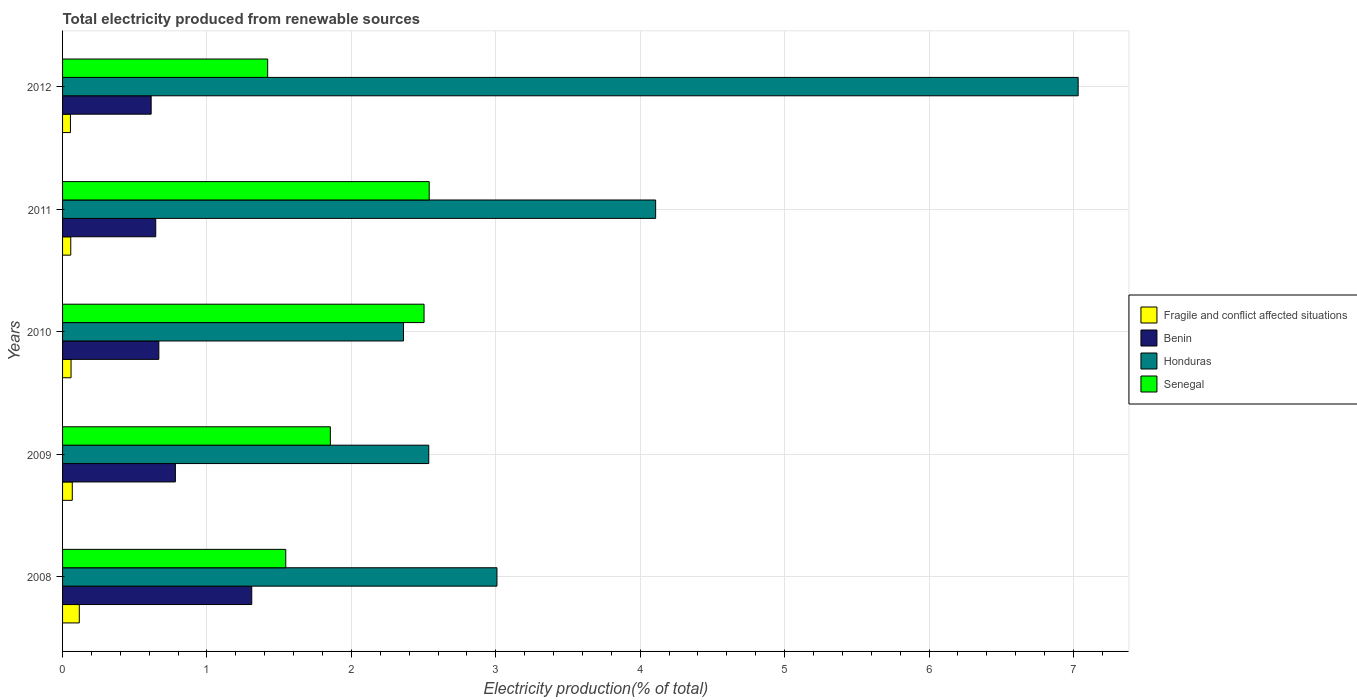How many different coloured bars are there?
Keep it short and to the point. 4. Are the number of bars on each tick of the Y-axis equal?
Provide a succinct answer. Yes. How many bars are there on the 2nd tick from the top?
Offer a terse response. 4. How many bars are there on the 4th tick from the bottom?
Keep it short and to the point. 4. In how many cases, is the number of bars for a given year not equal to the number of legend labels?
Your answer should be compact. 0. What is the total electricity produced in Benin in 2011?
Make the answer very short. 0.65. Across all years, what is the maximum total electricity produced in Honduras?
Make the answer very short. 7.03. Across all years, what is the minimum total electricity produced in Honduras?
Give a very brief answer. 2.36. In which year was the total electricity produced in Benin maximum?
Make the answer very short. 2008. What is the total total electricity produced in Fragile and conflict affected situations in the graph?
Your response must be concise. 0.35. What is the difference between the total electricity produced in Honduras in 2008 and that in 2009?
Keep it short and to the point. 0.47. What is the difference between the total electricity produced in Fragile and conflict affected situations in 2010 and the total electricity produced in Benin in 2012?
Offer a very short reply. -0.55. What is the average total electricity produced in Fragile and conflict affected situations per year?
Keep it short and to the point. 0.07. In the year 2008, what is the difference between the total electricity produced in Honduras and total electricity produced in Senegal?
Offer a very short reply. 1.46. In how many years, is the total electricity produced in Fragile and conflict affected situations greater than 3.8 %?
Your answer should be very brief. 0. What is the ratio of the total electricity produced in Honduras in 2008 to that in 2011?
Ensure brevity in your answer.  0.73. Is the difference between the total electricity produced in Honduras in 2008 and 2010 greater than the difference between the total electricity produced in Senegal in 2008 and 2010?
Offer a very short reply. Yes. What is the difference between the highest and the second highest total electricity produced in Senegal?
Provide a succinct answer. 0.04. What is the difference between the highest and the lowest total electricity produced in Fragile and conflict affected situations?
Your response must be concise. 0.06. In how many years, is the total electricity produced in Senegal greater than the average total electricity produced in Senegal taken over all years?
Ensure brevity in your answer.  2. What does the 3rd bar from the top in 2012 represents?
Offer a terse response. Benin. What does the 2nd bar from the bottom in 2008 represents?
Provide a succinct answer. Benin. What is the difference between two consecutive major ticks on the X-axis?
Your answer should be compact. 1. Does the graph contain grids?
Your answer should be compact. Yes. How many legend labels are there?
Provide a succinct answer. 4. How are the legend labels stacked?
Make the answer very short. Vertical. What is the title of the graph?
Give a very brief answer. Total electricity produced from renewable sources. What is the label or title of the Y-axis?
Provide a short and direct response. Years. What is the Electricity production(% of total) of Fragile and conflict affected situations in 2008?
Provide a short and direct response. 0.12. What is the Electricity production(% of total) in Benin in 2008?
Offer a very short reply. 1.31. What is the Electricity production(% of total) of Honduras in 2008?
Ensure brevity in your answer.  3.01. What is the Electricity production(% of total) of Senegal in 2008?
Ensure brevity in your answer.  1.55. What is the Electricity production(% of total) in Fragile and conflict affected situations in 2009?
Offer a very short reply. 0.07. What is the Electricity production(% of total) in Benin in 2009?
Give a very brief answer. 0.78. What is the Electricity production(% of total) in Honduras in 2009?
Offer a very short reply. 2.54. What is the Electricity production(% of total) of Senegal in 2009?
Offer a terse response. 1.85. What is the Electricity production(% of total) of Fragile and conflict affected situations in 2010?
Your response must be concise. 0.06. What is the Electricity production(% of total) of Benin in 2010?
Your answer should be very brief. 0.67. What is the Electricity production(% of total) in Honduras in 2010?
Your response must be concise. 2.36. What is the Electricity production(% of total) in Senegal in 2010?
Keep it short and to the point. 2.5. What is the Electricity production(% of total) of Fragile and conflict affected situations in 2011?
Your response must be concise. 0.06. What is the Electricity production(% of total) in Benin in 2011?
Give a very brief answer. 0.65. What is the Electricity production(% of total) of Honduras in 2011?
Offer a terse response. 4.11. What is the Electricity production(% of total) in Senegal in 2011?
Provide a short and direct response. 2.54. What is the Electricity production(% of total) of Fragile and conflict affected situations in 2012?
Your answer should be very brief. 0.05. What is the Electricity production(% of total) of Benin in 2012?
Your response must be concise. 0.61. What is the Electricity production(% of total) in Honduras in 2012?
Provide a short and direct response. 7.03. What is the Electricity production(% of total) of Senegal in 2012?
Offer a terse response. 1.42. Across all years, what is the maximum Electricity production(% of total) of Fragile and conflict affected situations?
Offer a terse response. 0.12. Across all years, what is the maximum Electricity production(% of total) of Benin?
Ensure brevity in your answer.  1.31. Across all years, what is the maximum Electricity production(% of total) in Honduras?
Keep it short and to the point. 7.03. Across all years, what is the maximum Electricity production(% of total) of Senegal?
Your response must be concise. 2.54. Across all years, what is the minimum Electricity production(% of total) in Fragile and conflict affected situations?
Give a very brief answer. 0.05. Across all years, what is the minimum Electricity production(% of total) in Benin?
Give a very brief answer. 0.61. Across all years, what is the minimum Electricity production(% of total) in Honduras?
Offer a very short reply. 2.36. Across all years, what is the minimum Electricity production(% of total) in Senegal?
Ensure brevity in your answer.  1.42. What is the total Electricity production(% of total) in Fragile and conflict affected situations in the graph?
Make the answer very short. 0.35. What is the total Electricity production(% of total) in Benin in the graph?
Your answer should be compact. 4.02. What is the total Electricity production(% of total) of Honduras in the graph?
Your answer should be compact. 19.04. What is the total Electricity production(% of total) in Senegal in the graph?
Keep it short and to the point. 9.86. What is the difference between the Electricity production(% of total) of Fragile and conflict affected situations in 2008 and that in 2009?
Keep it short and to the point. 0.05. What is the difference between the Electricity production(% of total) in Benin in 2008 and that in 2009?
Give a very brief answer. 0.53. What is the difference between the Electricity production(% of total) in Honduras in 2008 and that in 2009?
Ensure brevity in your answer.  0.47. What is the difference between the Electricity production(% of total) of Senegal in 2008 and that in 2009?
Give a very brief answer. -0.31. What is the difference between the Electricity production(% of total) of Fragile and conflict affected situations in 2008 and that in 2010?
Offer a very short reply. 0.06. What is the difference between the Electricity production(% of total) of Benin in 2008 and that in 2010?
Offer a very short reply. 0.64. What is the difference between the Electricity production(% of total) of Honduras in 2008 and that in 2010?
Ensure brevity in your answer.  0.65. What is the difference between the Electricity production(% of total) in Senegal in 2008 and that in 2010?
Make the answer very short. -0.96. What is the difference between the Electricity production(% of total) in Fragile and conflict affected situations in 2008 and that in 2011?
Make the answer very short. 0.06. What is the difference between the Electricity production(% of total) in Benin in 2008 and that in 2011?
Offer a very short reply. 0.66. What is the difference between the Electricity production(% of total) in Honduras in 2008 and that in 2011?
Your response must be concise. -1.1. What is the difference between the Electricity production(% of total) in Senegal in 2008 and that in 2011?
Make the answer very short. -0.99. What is the difference between the Electricity production(% of total) of Fragile and conflict affected situations in 2008 and that in 2012?
Provide a succinct answer. 0.06. What is the difference between the Electricity production(% of total) in Benin in 2008 and that in 2012?
Provide a succinct answer. 0.7. What is the difference between the Electricity production(% of total) of Honduras in 2008 and that in 2012?
Your answer should be compact. -4.02. What is the difference between the Electricity production(% of total) of Senegal in 2008 and that in 2012?
Offer a terse response. 0.13. What is the difference between the Electricity production(% of total) in Fragile and conflict affected situations in 2009 and that in 2010?
Give a very brief answer. 0.01. What is the difference between the Electricity production(% of total) in Benin in 2009 and that in 2010?
Your answer should be compact. 0.11. What is the difference between the Electricity production(% of total) of Honduras in 2009 and that in 2010?
Ensure brevity in your answer.  0.17. What is the difference between the Electricity production(% of total) of Senegal in 2009 and that in 2010?
Your answer should be compact. -0.65. What is the difference between the Electricity production(% of total) of Fragile and conflict affected situations in 2009 and that in 2011?
Provide a succinct answer. 0.01. What is the difference between the Electricity production(% of total) in Benin in 2009 and that in 2011?
Offer a very short reply. 0.14. What is the difference between the Electricity production(% of total) in Honduras in 2009 and that in 2011?
Ensure brevity in your answer.  -1.57. What is the difference between the Electricity production(% of total) of Senegal in 2009 and that in 2011?
Ensure brevity in your answer.  -0.68. What is the difference between the Electricity production(% of total) in Fragile and conflict affected situations in 2009 and that in 2012?
Keep it short and to the point. 0.01. What is the difference between the Electricity production(% of total) in Benin in 2009 and that in 2012?
Your response must be concise. 0.17. What is the difference between the Electricity production(% of total) in Honduras in 2009 and that in 2012?
Provide a succinct answer. -4.5. What is the difference between the Electricity production(% of total) in Senegal in 2009 and that in 2012?
Give a very brief answer. 0.43. What is the difference between the Electricity production(% of total) of Fragile and conflict affected situations in 2010 and that in 2011?
Your answer should be compact. 0. What is the difference between the Electricity production(% of total) of Benin in 2010 and that in 2011?
Provide a succinct answer. 0.02. What is the difference between the Electricity production(% of total) of Honduras in 2010 and that in 2011?
Your answer should be compact. -1.75. What is the difference between the Electricity production(% of total) in Senegal in 2010 and that in 2011?
Ensure brevity in your answer.  -0.04. What is the difference between the Electricity production(% of total) in Fragile and conflict affected situations in 2010 and that in 2012?
Keep it short and to the point. 0. What is the difference between the Electricity production(% of total) of Benin in 2010 and that in 2012?
Your response must be concise. 0.05. What is the difference between the Electricity production(% of total) of Honduras in 2010 and that in 2012?
Provide a short and direct response. -4.67. What is the difference between the Electricity production(% of total) of Senegal in 2010 and that in 2012?
Your response must be concise. 1.08. What is the difference between the Electricity production(% of total) of Fragile and conflict affected situations in 2011 and that in 2012?
Provide a succinct answer. 0. What is the difference between the Electricity production(% of total) of Benin in 2011 and that in 2012?
Offer a terse response. 0.03. What is the difference between the Electricity production(% of total) of Honduras in 2011 and that in 2012?
Offer a terse response. -2.93. What is the difference between the Electricity production(% of total) in Senegal in 2011 and that in 2012?
Your answer should be compact. 1.12. What is the difference between the Electricity production(% of total) in Fragile and conflict affected situations in 2008 and the Electricity production(% of total) in Benin in 2009?
Your response must be concise. -0.67. What is the difference between the Electricity production(% of total) in Fragile and conflict affected situations in 2008 and the Electricity production(% of total) in Honduras in 2009?
Provide a short and direct response. -2.42. What is the difference between the Electricity production(% of total) in Fragile and conflict affected situations in 2008 and the Electricity production(% of total) in Senegal in 2009?
Keep it short and to the point. -1.74. What is the difference between the Electricity production(% of total) in Benin in 2008 and the Electricity production(% of total) in Honduras in 2009?
Offer a very short reply. -1.23. What is the difference between the Electricity production(% of total) in Benin in 2008 and the Electricity production(% of total) in Senegal in 2009?
Your answer should be very brief. -0.54. What is the difference between the Electricity production(% of total) of Honduras in 2008 and the Electricity production(% of total) of Senegal in 2009?
Your response must be concise. 1.15. What is the difference between the Electricity production(% of total) of Fragile and conflict affected situations in 2008 and the Electricity production(% of total) of Benin in 2010?
Your response must be concise. -0.55. What is the difference between the Electricity production(% of total) of Fragile and conflict affected situations in 2008 and the Electricity production(% of total) of Honduras in 2010?
Offer a very short reply. -2.25. What is the difference between the Electricity production(% of total) of Fragile and conflict affected situations in 2008 and the Electricity production(% of total) of Senegal in 2010?
Offer a terse response. -2.39. What is the difference between the Electricity production(% of total) of Benin in 2008 and the Electricity production(% of total) of Honduras in 2010?
Give a very brief answer. -1.05. What is the difference between the Electricity production(% of total) of Benin in 2008 and the Electricity production(% of total) of Senegal in 2010?
Ensure brevity in your answer.  -1.19. What is the difference between the Electricity production(% of total) of Honduras in 2008 and the Electricity production(% of total) of Senegal in 2010?
Your response must be concise. 0.5. What is the difference between the Electricity production(% of total) in Fragile and conflict affected situations in 2008 and the Electricity production(% of total) in Benin in 2011?
Keep it short and to the point. -0.53. What is the difference between the Electricity production(% of total) of Fragile and conflict affected situations in 2008 and the Electricity production(% of total) of Honduras in 2011?
Provide a succinct answer. -3.99. What is the difference between the Electricity production(% of total) of Fragile and conflict affected situations in 2008 and the Electricity production(% of total) of Senegal in 2011?
Offer a terse response. -2.42. What is the difference between the Electricity production(% of total) in Benin in 2008 and the Electricity production(% of total) in Honduras in 2011?
Your answer should be very brief. -2.8. What is the difference between the Electricity production(% of total) of Benin in 2008 and the Electricity production(% of total) of Senegal in 2011?
Make the answer very short. -1.23. What is the difference between the Electricity production(% of total) in Honduras in 2008 and the Electricity production(% of total) in Senegal in 2011?
Give a very brief answer. 0.47. What is the difference between the Electricity production(% of total) of Fragile and conflict affected situations in 2008 and the Electricity production(% of total) of Benin in 2012?
Offer a terse response. -0.5. What is the difference between the Electricity production(% of total) of Fragile and conflict affected situations in 2008 and the Electricity production(% of total) of Honduras in 2012?
Ensure brevity in your answer.  -6.92. What is the difference between the Electricity production(% of total) of Fragile and conflict affected situations in 2008 and the Electricity production(% of total) of Senegal in 2012?
Your answer should be compact. -1.3. What is the difference between the Electricity production(% of total) of Benin in 2008 and the Electricity production(% of total) of Honduras in 2012?
Give a very brief answer. -5.72. What is the difference between the Electricity production(% of total) of Benin in 2008 and the Electricity production(% of total) of Senegal in 2012?
Give a very brief answer. -0.11. What is the difference between the Electricity production(% of total) of Honduras in 2008 and the Electricity production(% of total) of Senegal in 2012?
Offer a terse response. 1.59. What is the difference between the Electricity production(% of total) in Fragile and conflict affected situations in 2009 and the Electricity production(% of total) in Benin in 2010?
Your response must be concise. -0.6. What is the difference between the Electricity production(% of total) in Fragile and conflict affected situations in 2009 and the Electricity production(% of total) in Honduras in 2010?
Provide a short and direct response. -2.29. What is the difference between the Electricity production(% of total) in Fragile and conflict affected situations in 2009 and the Electricity production(% of total) in Senegal in 2010?
Ensure brevity in your answer.  -2.44. What is the difference between the Electricity production(% of total) in Benin in 2009 and the Electricity production(% of total) in Honduras in 2010?
Offer a terse response. -1.58. What is the difference between the Electricity production(% of total) in Benin in 2009 and the Electricity production(% of total) in Senegal in 2010?
Give a very brief answer. -1.72. What is the difference between the Electricity production(% of total) of Honduras in 2009 and the Electricity production(% of total) of Senegal in 2010?
Offer a terse response. 0.03. What is the difference between the Electricity production(% of total) in Fragile and conflict affected situations in 2009 and the Electricity production(% of total) in Benin in 2011?
Keep it short and to the point. -0.58. What is the difference between the Electricity production(% of total) in Fragile and conflict affected situations in 2009 and the Electricity production(% of total) in Honduras in 2011?
Your answer should be compact. -4.04. What is the difference between the Electricity production(% of total) of Fragile and conflict affected situations in 2009 and the Electricity production(% of total) of Senegal in 2011?
Offer a terse response. -2.47. What is the difference between the Electricity production(% of total) of Benin in 2009 and the Electricity production(% of total) of Honduras in 2011?
Keep it short and to the point. -3.33. What is the difference between the Electricity production(% of total) of Benin in 2009 and the Electricity production(% of total) of Senegal in 2011?
Your response must be concise. -1.76. What is the difference between the Electricity production(% of total) in Honduras in 2009 and the Electricity production(% of total) in Senegal in 2011?
Provide a short and direct response. -0. What is the difference between the Electricity production(% of total) in Fragile and conflict affected situations in 2009 and the Electricity production(% of total) in Benin in 2012?
Make the answer very short. -0.55. What is the difference between the Electricity production(% of total) in Fragile and conflict affected situations in 2009 and the Electricity production(% of total) in Honduras in 2012?
Offer a terse response. -6.97. What is the difference between the Electricity production(% of total) in Fragile and conflict affected situations in 2009 and the Electricity production(% of total) in Senegal in 2012?
Provide a succinct answer. -1.35. What is the difference between the Electricity production(% of total) of Benin in 2009 and the Electricity production(% of total) of Honduras in 2012?
Provide a short and direct response. -6.25. What is the difference between the Electricity production(% of total) of Benin in 2009 and the Electricity production(% of total) of Senegal in 2012?
Provide a succinct answer. -0.64. What is the difference between the Electricity production(% of total) of Honduras in 2009 and the Electricity production(% of total) of Senegal in 2012?
Ensure brevity in your answer.  1.12. What is the difference between the Electricity production(% of total) in Fragile and conflict affected situations in 2010 and the Electricity production(% of total) in Benin in 2011?
Give a very brief answer. -0.59. What is the difference between the Electricity production(% of total) in Fragile and conflict affected situations in 2010 and the Electricity production(% of total) in Honduras in 2011?
Your answer should be compact. -4.05. What is the difference between the Electricity production(% of total) in Fragile and conflict affected situations in 2010 and the Electricity production(% of total) in Senegal in 2011?
Keep it short and to the point. -2.48. What is the difference between the Electricity production(% of total) in Benin in 2010 and the Electricity production(% of total) in Honduras in 2011?
Your answer should be compact. -3.44. What is the difference between the Electricity production(% of total) in Benin in 2010 and the Electricity production(% of total) in Senegal in 2011?
Provide a short and direct response. -1.87. What is the difference between the Electricity production(% of total) of Honduras in 2010 and the Electricity production(% of total) of Senegal in 2011?
Your answer should be very brief. -0.18. What is the difference between the Electricity production(% of total) in Fragile and conflict affected situations in 2010 and the Electricity production(% of total) in Benin in 2012?
Offer a terse response. -0.55. What is the difference between the Electricity production(% of total) of Fragile and conflict affected situations in 2010 and the Electricity production(% of total) of Honduras in 2012?
Your answer should be compact. -6.97. What is the difference between the Electricity production(% of total) in Fragile and conflict affected situations in 2010 and the Electricity production(% of total) in Senegal in 2012?
Provide a succinct answer. -1.36. What is the difference between the Electricity production(% of total) of Benin in 2010 and the Electricity production(% of total) of Honduras in 2012?
Your answer should be compact. -6.37. What is the difference between the Electricity production(% of total) in Benin in 2010 and the Electricity production(% of total) in Senegal in 2012?
Make the answer very short. -0.75. What is the difference between the Electricity production(% of total) in Honduras in 2010 and the Electricity production(% of total) in Senegal in 2012?
Give a very brief answer. 0.94. What is the difference between the Electricity production(% of total) of Fragile and conflict affected situations in 2011 and the Electricity production(% of total) of Benin in 2012?
Provide a succinct answer. -0.56. What is the difference between the Electricity production(% of total) of Fragile and conflict affected situations in 2011 and the Electricity production(% of total) of Honduras in 2012?
Your answer should be compact. -6.98. What is the difference between the Electricity production(% of total) of Fragile and conflict affected situations in 2011 and the Electricity production(% of total) of Senegal in 2012?
Your response must be concise. -1.36. What is the difference between the Electricity production(% of total) in Benin in 2011 and the Electricity production(% of total) in Honduras in 2012?
Give a very brief answer. -6.39. What is the difference between the Electricity production(% of total) in Benin in 2011 and the Electricity production(% of total) in Senegal in 2012?
Provide a succinct answer. -0.78. What is the difference between the Electricity production(% of total) in Honduras in 2011 and the Electricity production(% of total) in Senegal in 2012?
Make the answer very short. 2.69. What is the average Electricity production(% of total) of Fragile and conflict affected situations per year?
Offer a terse response. 0.07. What is the average Electricity production(% of total) in Benin per year?
Your answer should be very brief. 0.8. What is the average Electricity production(% of total) in Honduras per year?
Make the answer very short. 3.81. What is the average Electricity production(% of total) of Senegal per year?
Ensure brevity in your answer.  1.97. In the year 2008, what is the difference between the Electricity production(% of total) of Fragile and conflict affected situations and Electricity production(% of total) of Benin?
Your response must be concise. -1.19. In the year 2008, what is the difference between the Electricity production(% of total) of Fragile and conflict affected situations and Electricity production(% of total) of Honduras?
Your response must be concise. -2.89. In the year 2008, what is the difference between the Electricity production(% of total) of Fragile and conflict affected situations and Electricity production(% of total) of Senegal?
Ensure brevity in your answer.  -1.43. In the year 2008, what is the difference between the Electricity production(% of total) in Benin and Electricity production(% of total) in Honduras?
Your answer should be very brief. -1.7. In the year 2008, what is the difference between the Electricity production(% of total) of Benin and Electricity production(% of total) of Senegal?
Offer a terse response. -0.24. In the year 2008, what is the difference between the Electricity production(% of total) of Honduras and Electricity production(% of total) of Senegal?
Your answer should be very brief. 1.46. In the year 2009, what is the difference between the Electricity production(% of total) of Fragile and conflict affected situations and Electricity production(% of total) of Benin?
Provide a succinct answer. -0.71. In the year 2009, what is the difference between the Electricity production(% of total) of Fragile and conflict affected situations and Electricity production(% of total) of Honduras?
Keep it short and to the point. -2.47. In the year 2009, what is the difference between the Electricity production(% of total) of Fragile and conflict affected situations and Electricity production(% of total) of Senegal?
Offer a terse response. -1.79. In the year 2009, what is the difference between the Electricity production(% of total) of Benin and Electricity production(% of total) of Honduras?
Your answer should be compact. -1.75. In the year 2009, what is the difference between the Electricity production(% of total) in Benin and Electricity production(% of total) in Senegal?
Offer a terse response. -1.07. In the year 2009, what is the difference between the Electricity production(% of total) in Honduras and Electricity production(% of total) in Senegal?
Ensure brevity in your answer.  0.68. In the year 2010, what is the difference between the Electricity production(% of total) in Fragile and conflict affected situations and Electricity production(% of total) in Benin?
Provide a short and direct response. -0.61. In the year 2010, what is the difference between the Electricity production(% of total) of Fragile and conflict affected situations and Electricity production(% of total) of Honduras?
Your response must be concise. -2.3. In the year 2010, what is the difference between the Electricity production(% of total) in Fragile and conflict affected situations and Electricity production(% of total) in Senegal?
Make the answer very short. -2.44. In the year 2010, what is the difference between the Electricity production(% of total) of Benin and Electricity production(% of total) of Honduras?
Give a very brief answer. -1.69. In the year 2010, what is the difference between the Electricity production(% of total) of Benin and Electricity production(% of total) of Senegal?
Your answer should be very brief. -1.84. In the year 2010, what is the difference between the Electricity production(% of total) in Honduras and Electricity production(% of total) in Senegal?
Provide a succinct answer. -0.14. In the year 2011, what is the difference between the Electricity production(% of total) in Fragile and conflict affected situations and Electricity production(% of total) in Benin?
Offer a terse response. -0.59. In the year 2011, what is the difference between the Electricity production(% of total) of Fragile and conflict affected situations and Electricity production(% of total) of Honduras?
Your response must be concise. -4.05. In the year 2011, what is the difference between the Electricity production(% of total) in Fragile and conflict affected situations and Electricity production(% of total) in Senegal?
Keep it short and to the point. -2.48. In the year 2011, what is the difference between the Electricity production(% of total) in Benin and Electricity production(% of total) in Honduras?
Give a very brief answer. -3.46. In the year 2011, what is the difference between the Electricity production(% of total) of Benin and Electricity production(% of total) of Senegal?
Your answer should be very brief. -1.89. In the year 2011, what is the difference between the Electricity production(% of total) of Honduras and Electricity production(% of total) of Senegal?
Give a very brief answer. 1.57. In the year 2012, what is the difference between the Electricity production(% of total) of Fragile and conflict affected situations and Electricity production(% of total) of Benin?
Your answer should be compact. -0.56. In the year 2012, what is the difference between the Electricity production(% of total) in Fragile and conflict affected situations and Electricity production(% of total) in Honduras?
Your answer should be compact. -6.98. In the year 2012, what is the difference between the Electricity production(% of total) of Fragile and conflict affected situations and Electricity production(% of total) of Senegal?
Your answer should be very brief. -1.37. In the year 2012, what is the difference between the Electricity production(% of total) in Benin and Electricity production(% of total) in Honduras?
Provide a short and direct response. -6.42. In the year 2012, what is the difference between the Electricity production(% of total) of Benin and Electricity production(% of total) of Senegal?
Your answer should be very brief. -0.81. In the year 2012, what is the difference between the Electricity production(% of total) in Honduras and Electricity production(% of total) in Senegal?
Make the answer very short. 5.61. What is the ratio of the Electricity production(% of total) of Fragile and conflict affected situations in 2008 to that in 2009?
Ensure brevity in your answer.  1.72. What is the ratio of the Electricity production(% of total) in Benin in 2008 to that in 2009?
Keep it short and to the point. 1.68. What is the ratio of the Electricity production(% of total) in Honduras in 2008 to that in 2009?
Offer a very short reply. 1.19. What is the ratio of the Electricity production(% of total) of Senegal in 2008 to that in 2009?
Keep it short and to the point. 0.83. What is the ratio of the Electricity production(% of total) in Fragile and conflict affected situations in 2008 to that in 2010?
Provide a succinct answer. 1.97. What is the ratio of the Electricity production(% of total) in Benin in 2008 to that in 2010?
Ensure brevity in your answer.  1.97. What is the ratio of the Electricity production(% of total) of Honduras in 2008 to that in 2010?
Give a very brief answer. 1.27. What is the ratio of the Electricity production(% of total) of Senegal in 2008 to that in 2010?
Your answer should be very brief. 0.62. What is the ratio of the Electricity production(% of total) in Fragile and conflict affected situations in 2008 to that in 2011?
Give a very brief answer. 2.04. What is the ratio of the Electricity production(% of total) in Benin in 2008 to that in 2011?
Your answer should be compact. 2.03. What is the ratio of the Electricity production(% of total) of Honduras in 2008 to that in 2011?
Your response must be concise. 0.73. What is the ratio of the Electricity production(% of total) of Senegal in 2008 to that in 2011?
Ensure brevity in your answer.  0.61. What is the ratio of the Electricity production(% of total) of Fragile and conflict affected situations in 2008 to that in 2012?
Offer a very short reply. 2.12. What is the ratio of the Electricity production(% of total) of Benin in 2008 to that in 2012?
Your answer should be compact. 2.14. What is the ratio of the Electricity production(% of total) in Honduras in 2008 to that in 2012?
Your answer should be compact. 0.43. What is the ratio of the Electricity production(% of total) in Senegal in 2008 to that in 2012?
Make the answer very short. 1.09. What is the ratio of the Electricity production(% of total) of Fragile and conflict affected situations in 2009 to that in 2010?
Your answer should be compact. 1.15. What is the ratio of the Electricity production(% of total) of Benin in 2009 to that in 2010?
Offer a terse response. 1.17. What is the ratio of the Electricity production(% of total) of Honduras in 2009 to that in 2010?
Offer a terse response. 1.07. What is the ratio of the Electricity production(% of total) in Senegal in 2009 to that in 2010?
Keep it short and to the point. 0.74. What is the ratio of the Electricity production(% of total) in Fragile and conflict affected situations in 2009 to that in 2011?
Offer a terse response. 1.18. What is the ratio of the Electricity production(% of total) of Benin in 2009 to that in 2011?
Make the answer very short. 1.21. What is the ratio of the Electricity production(% of total) in Honduras in 2009 to that in 2011?
Provide a succinct answer. 0.62. What is the ratio of the Electricity production(% of total) of Senegal in 2009 to that in 2011?
Offer a very short reply. 0.73. What is the ratio of the Electricity production(% of total) in Fragile and conflict affected situations in 2009 to that in 2012?
Your answer should be very brief. 1.23. What is the ratio of the Electricity production(% of total) in Benin in 2009 to that in 2012?
Provide a succinct answer. 1.27. What is the ratio of the Electricity production(% of total) of Honduras in 2009 to that in 2012?
Provide a short and direct response. 0.36. What is the ratio of the Electricity production(% of total) in Senegal in 2009 to that in 2012?
Ensure brevity in your answer.  1.31. What is the ratio of the Electricity production(% of total) of Fragile and conflict affected situations in 2010 to that in 2011?
Provide a succinct answer. 1.03. What is the ratio of the Electricity production(% of total) of Honduras in 2010 to that in 2011?
Offer a very short reply. 0.57. What is the ratio of the Electricity production(% of total) of Fragile and conflict affected situations in 2010 to that in 2012?
Provide a succinct answer. 1.08. What is the ratio of the Electricity production(% of total) of Benin in 2010 to that in 2012?
Make the answer very short. 1.09. What is the ratio of the Electricity production(% of total) in Honduras in 2010 to that in 2012?
Your answer should be compact. 0.34. What is the ratio of the Electricity production(% of total) in Senegal in 2010 to that in 2012?
Your answer should be compact. 1.76. What is the ratio of the Electricity production(% of total) of Fragile and conflict affected situations in 2011 to that in 2012?
Make the answer very short. 1.04. What is the ratio of the Electricity production(% of total) of Benin in 2011 to that in 2012?
Your response must be concise. 1.05. What is the ratio of the Electricity production(% of total) of Honduras in 2011 to that in 2012?
Provide a short and direct response. 0.58. What is the ratio of the Electricity production(% of total) in Senegal in 2011 to that in 2012?
Offer a terse response. 1.79. What is the difference between the highest and the second highest Electricity production(% of total) in Fragile and conflict affected situations?
Provide a short and direct response. 0.05. What is the difference between the highest and the second highest Electricity production(% of total) in Benin?
Keep it short and to the point. 0.53. What is the difference between the highest and the second highest Electricity production(% of total) in Honduras?
Keep it short and to the point. 2.93. What is the difference between the highest and the second highest Electricity production(% of total) in Senegal?
Make the answer very short. 0.04. What is the difference between the highest and the lowest Electricity production(% of total) of Fragile and conflict affected situations?
Your answer should be very brief. 0.06. What is the difference between the highest and the lowest Electricity production(% of total) in Benin?
Ensure brevity in your answer.  0.7. What is the difference between the highest and the lowest Electricity production(% of total) in Honduras?
Your answer should be compact. 4.67. What is the difference between the highest and the lowest Electricity production(% of total) of Senegal?
Your response must be concise. 1.12. 